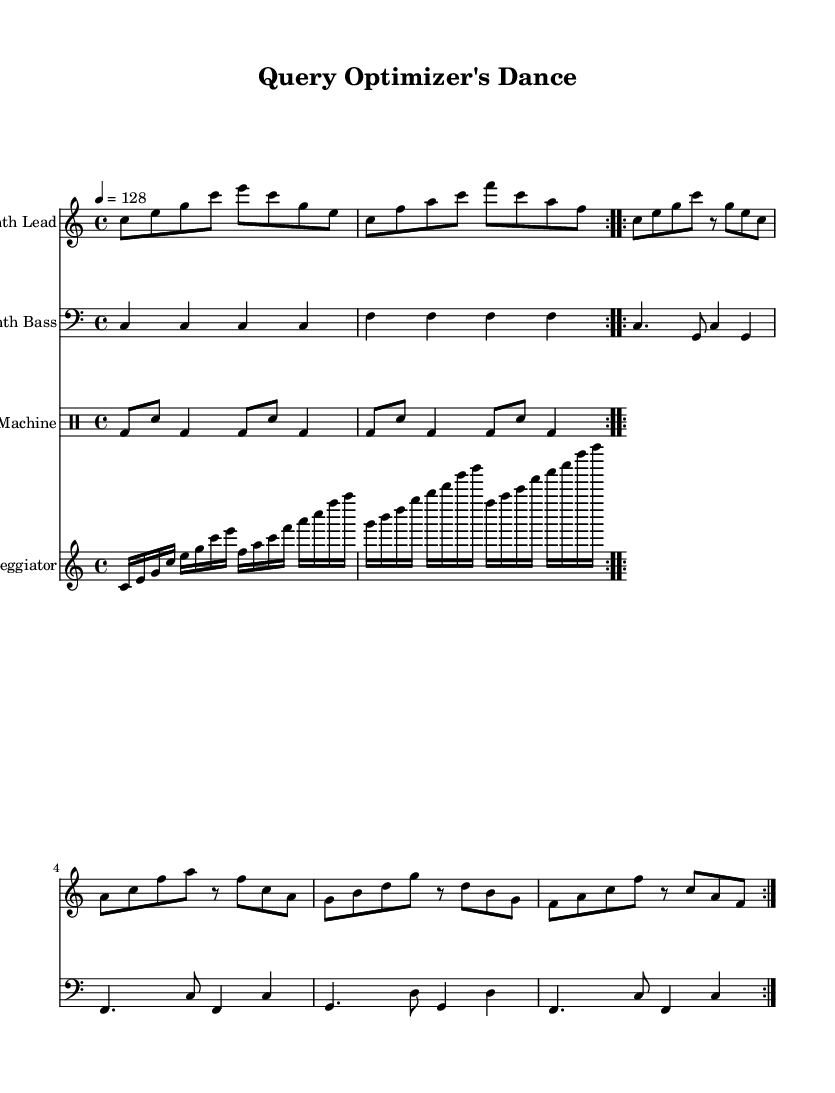What is the key signature of this music? The key signature is C major, which has no sharps or flats.
Answer: C major What is the time signature of this music? The time signature is found at the beginning of the sheet music; it is four beats in a measure.
Answer: 4/4 What is the tempo marking of this piece? The tempo marking indicates how fast the music should be played; here, it is specified with a metronome marking.
Answer: 128 How many bars are in the intro section? By counting the measures in the intro part of the synth lead, we find that it repeats a specific pattern twice, making it easy to count.
Answer: 4 Which instrument plays the main melodic theme? This sheet music specifies the instruments for each staff, and the instrument that carries the main melody is indicated above one of the staves.
Answer: Synth Lead What rhythmic pattern does the drum machine play? The drum pattern consists of alternating bass drum and snare hits and can be gleaned from the drum staff, showing a consistent repeating structure.
Answer: Bass drum and snare In what way does the arpeggiator contribute to the music's texture? The arpeggiator plays rapid, cascading notes that provide a rhythmic and harmonic foundation, visually seen through the multiple subdivisions in the staff.
Answer: Textural depth 